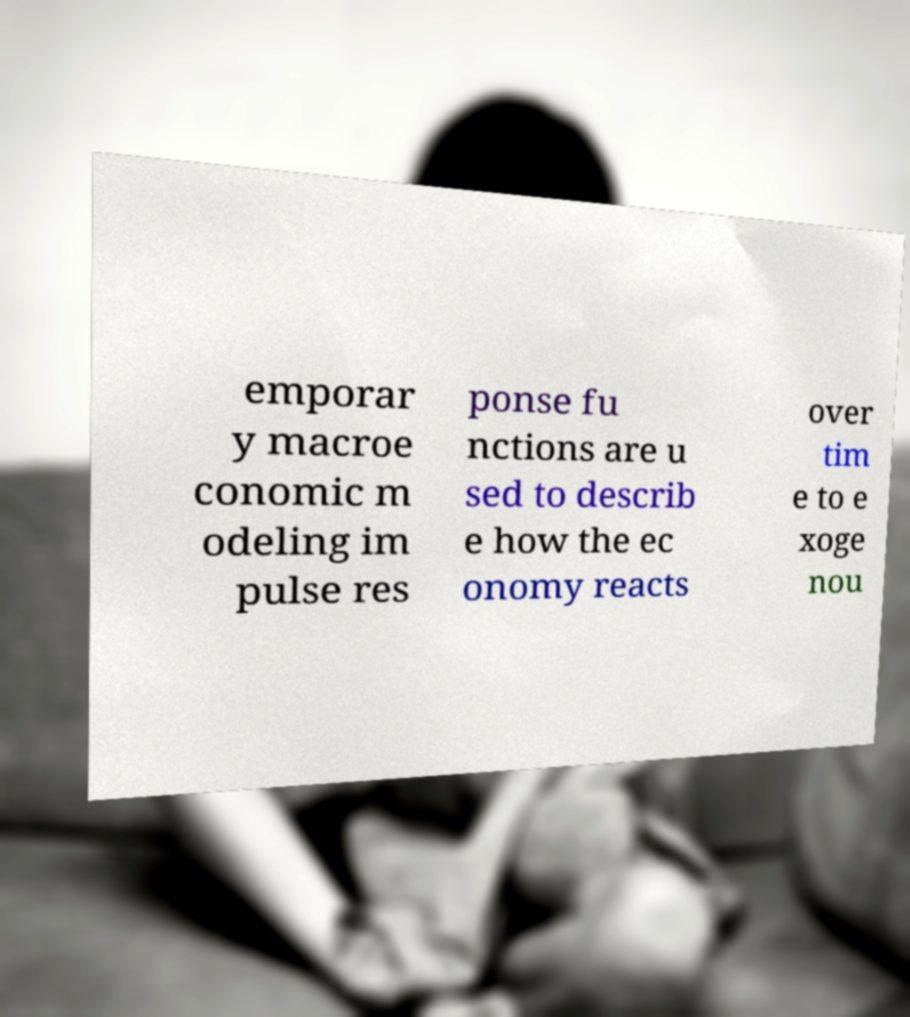For documentation purposes, I need the text within this image transcribed. Could you provide that? emporar y macroe conomic m odeling im pulse res ponse fu nctions are u sed to describ e how the ec onomy reacts over tim e to e xoge nou 